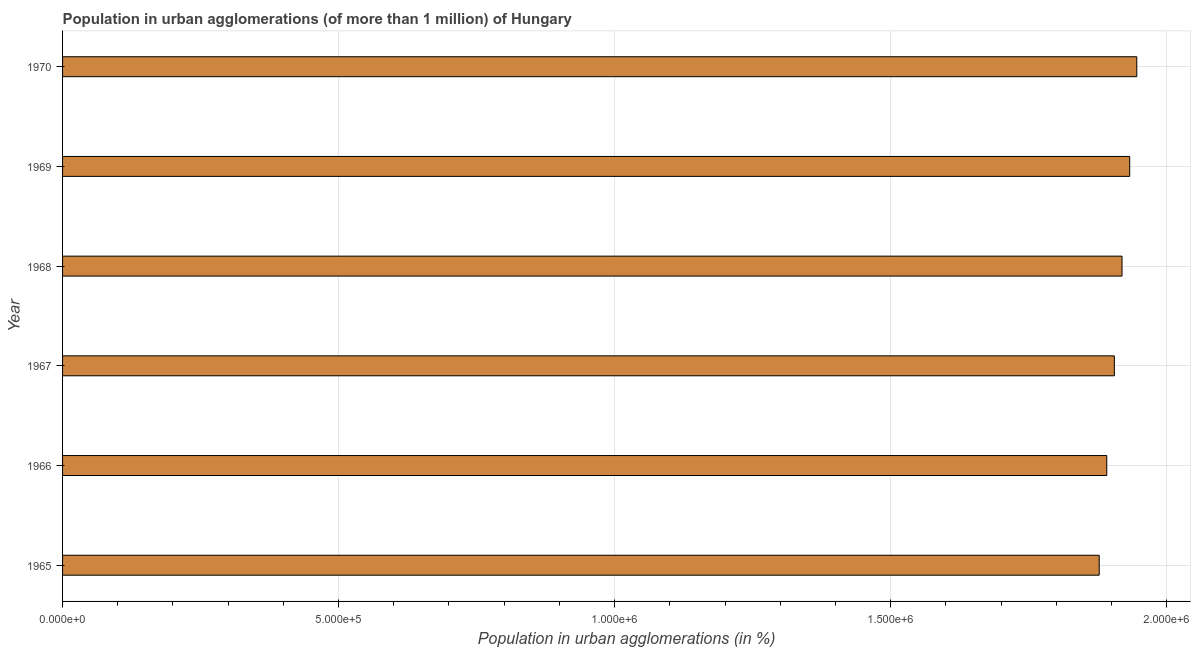Does the graph contain any zero values?
Ensure brevity in your answer.  No. What is the title of the graph?
Your answer should be very brief. Population in urban agglomerations (of more than 1 million) of Hungary. What is the label or title of the X-axis?
Keep it short and to the point. Population in urban agglomerations (in %). What is the population in urban agglomerations in 1966?
Keep it short and to the point. 1.89e+06. Across all years, what is the maximum population in urban agglomerations?
Your response must be concise. 1.95e+06. Across all years, what is the minimum population in urban agglomerations?
Your answer should be very brief. 1.88e+06. In which year was the population in urban agglomerations minimum?
Ensure brevity in your answer.  1965. What is the sum of the population in urban agglomerations?
Give a very brief answer. 1.15e+07. What is the difference between the population in urban agglomerations in 1967 and 1970?
Provide a short and direct response. -4.06e+04. What is the average population in urban agglomerations per year?
Offer a very short reply. 1.91e+06. What is the median population in urban agglomerations?
Your answer should be compact. 1.91e+06. In how many years, is the population in urban agglomerations greater than 1300000 %?
Your answer should be very brief. 6. Do a majority of the years between 1965 and 1970 (inclusive) have population in urban agglomerations greater than 1000000 %?
Your answer should be compact. Yes. What is the ratio of the population in urban agglomerations in 1965 to that in 1967?
Make the answer very short. 0.99. Is the difference between the population in urban agglomerations in 1965 and 1969 greater than the difference between any two years?
Your answer should be very brief. No. What is the difference between the highest and the second highest population in urban agglomerations?
Offer a terse response. 1.28e+04. What is the difference between the highest and the lowest population in urban agglomerations?
Your answer should be very brief. 6.80e+04. What is the Population in urban agglomerations (in %) in 1965?
Make the answer very short. 1.88e+06. What is the Population in urban agglomerations (in %) of 1966?
Your answer should be very brief. 1.89e+06. What is the Population in urban agglomerations (in %) of 1967?
Keep it short and to the point. 1.91e+06. What is the Population in urban agglomerations (in %) in 1968?
Your answer should be very brief. 1.92e+06. What is the Population in urban agglomerations (in %) of 1969?
Provide a succinct answer. 1.93e+06. What is the Population in urban agglomerations (in %) of 1970?
Provide a short and direct response. 1.95e+06. What is the difference between the Population in urban agglomerations (in %) in 1965 and 1966?
Ensure brevity in your answer.  -1.37e+04. What is the difference between the Population in urban agglomerations (in %) in 1965 and 1967?
Keep it short and to the point. -2.74e+04. What is the difference between the Population in urban agglomerations (in %) in 1965 and 1968?
Your answer should be compact. -4.13e+04. What is the difference between the Population in urban agglomerations (in %) in 1965 and 1969?
Your answer should be very brief. -5.52e+04. What is the difference between the Population in urban agglomerations (in %) in 1965 and 1970?
Offer a very short reply. -6.80e+04. What is the difference between the Population in urban agglomerations (in %) in 1966 and 1967?
Offer a very short reply. -1.38e+04. What is the difference between the Population in urban agglomerations (in %) in 1966 and 1968?
Your answer should be compact. -2.76e+04. What is the difference between the Population in urban agglomerations (in %) in 1966 and 1969?
Give a very brief answer. -4.16e+04. What is the difference between the Population in urban agglomerations (in %) in 1966 and 1970?
Your answer should be very brief. -5.44e+04. What is the difference between the Population in urban agglomerations (in %) in 1967 and 1968?
Provide a short and direct response. -1.39e+04. What is the difference between the Population in urban agglomerations (in %) in 1967 and 1969?
Provide a succinct answer. -2.78e+04. What is the difference between the Population in urban agglomerations (in %) in 1967 and 1970?
Offer a very short reply. -4.06e+04. What is the difference between the Population in urban agglomerations (in %) in 1968 and 1969?
Offer a terse response. -1.39e+04. What is the difference between the Population in urban agglomerations (in %) in 1968 and 1970?
Ensure brevity in your answer.  -2.68e+04. What is the difference between the Population in urban agglomerations (in %) in 1969 and 1970?
Your answer should be very brief. -1.28e+04. What is the ratio of the Population in urban agglomerations (in %) in 1965 to that in 1968?
Give a very brief answer. 0.98. What is the ratio of the Population in urban agglomerations (in %) in 1965 to that in 1969?
Keep it short and to the point. 0.97. What is the ratio of the Population in urban agglomerations (in %) in 1965 to that in 1970?
Offer a very short reply. 0.96. What is the ratio of the Population in urban agglomerations (in %) in 1966 to that in 1968?
Offer a very short reply. 0.99. What is the ratio of the Population in urban agglomerations (in %) in 1967 to that in 1968?
Your answer should be very brief. 0.99. What is the ratio of the Population in urban agglomerations (in %) in 1967 to that in 1969?
Your answer should be compact. 0.99. What is the ratio of the Population in urban agglomerations (in %) in 1967 to that in 1970?
Make the answer very short. 0.98. 